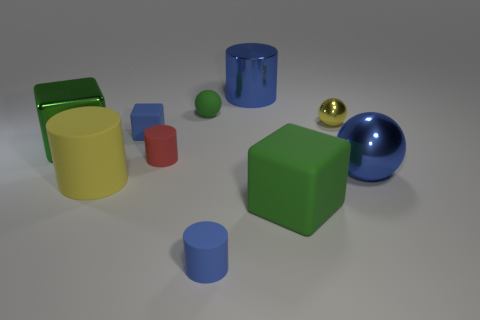Subtract all small blue matte blocks. How many blocks are left? 2 Subtract all green cylinders. How many green blocks are left? 2 Subtract all blue balls. How many balls are left? 2 Subtract all balls. How many objects are left? 7 Add 4 small green rubber spheres. How many small green rubber spheres exist? 5 Subtract 0 yellow cubes. How many objects are left? 10 Subtract 1 spheres. How many spheres are left? 2 Subtract all cyan balls. Subtract all purple cubes. How many balls are left? 3 Subtract all big blue cylinders. Subtract all tiny metal things. How many objects are left? 8 Add 7 big green matte cubes. How many big green matte cubes are left? 8 